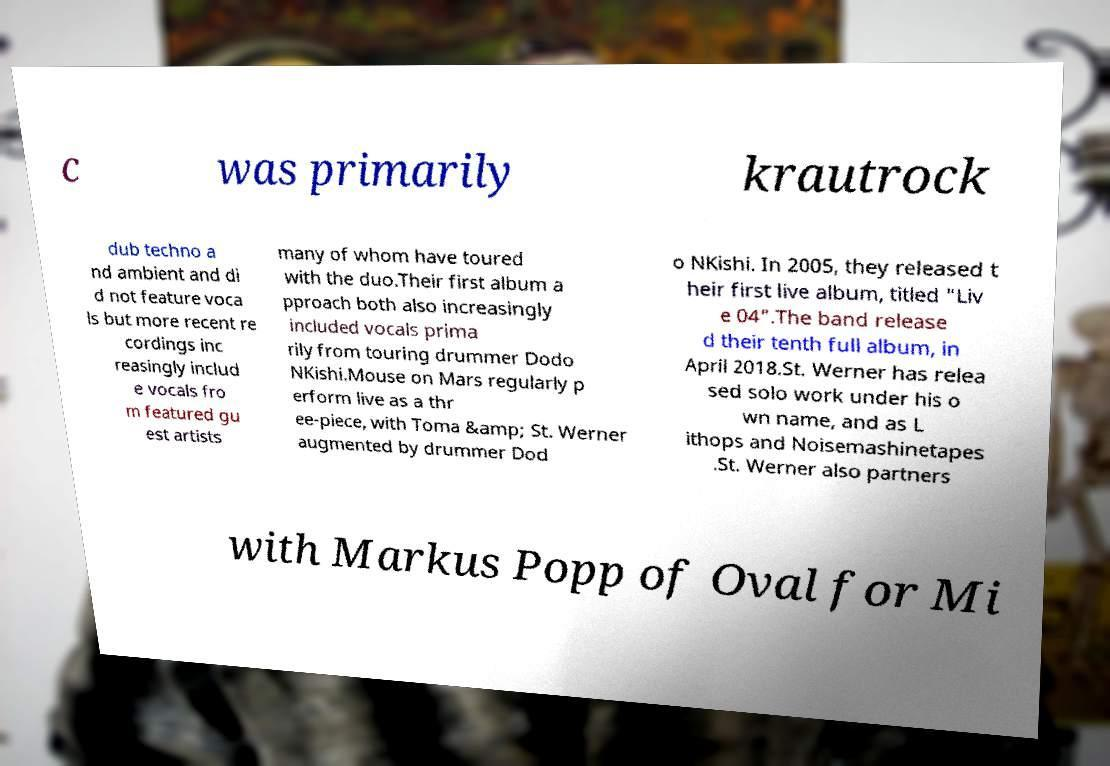Could you assist in decoding the text presented in this image and type it out clearly? c was primarily krautrock dub techno a nd ambient and di d not feature voca ls but more recent re cordings inc reasingly includ e vocals fro m featured gu est artists many of whom have toured with the duo.Their first album a pproach both also increasingly included vocals prima rily from touring drummer Dodo NKishi.Mouse on Mars regularly p erform live as a thr ee-piece, with Toma &amp; St. Werner augmented by drummer Dod o NKishi. In 2005, they released t heir first live album, titled "Liv e 04".The band release d their tenth full album, in April 2018.St. Werner has relea sed solo work under his o wn name, and as L ithops and Noisemashinetapes .St. Werner also partners with Markus Popp of Oval for Mi 